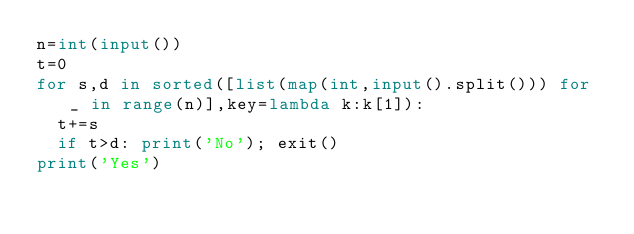Convert code to text. <code><loc_0><loc_0><loc_500><loc_500><_Python_>n=int(input())
t=0
for s,d in sorted([list(map(int,input().split())) for _ in range(n)],key=lambda k:k[1]):
  t+=s
  if t>d: print('No'); exit()
print('Yes')</code> 